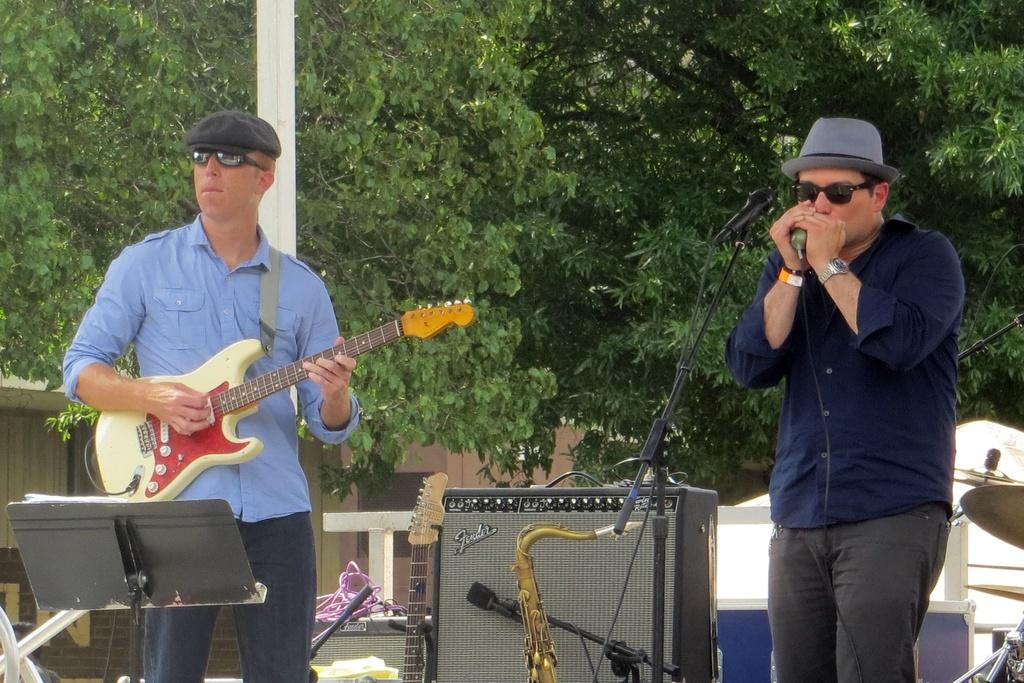What is the main activity being performed by the person on the left side of the image? The person on the left side of the image is playing guitar. What is the main activity being performed by the person on the right side of the image? The person on the right side of the image is singing in front of a mic. What can be seen behind the two people in the image? There are musical instruments behind the two people. What is visible in the background of the image? There are trees visible in the background of the image. What type of gold patch can be seen on the guitar in the image? There is no gold patch visible on the guitar in the image. 